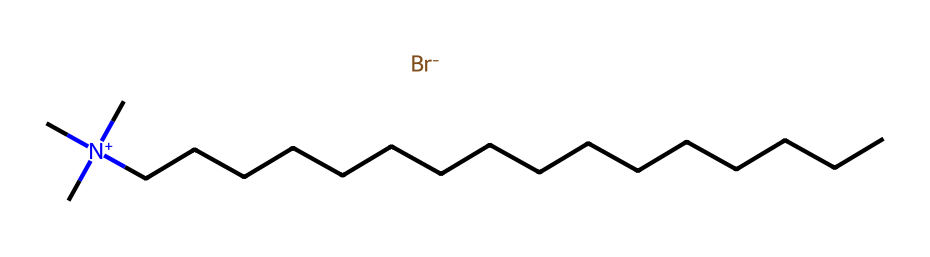What is the total number of carbon atoms in cetrimonium bromide? By examining the SMILES representation, the part "CCCCCCCCCCCCCCCC" indicates a straight chain of 16 carbon atoms, since each "C" represents a carbon atom in the chain.
Answer: 16 How many nitrogen atoms are present in cetrimonium bromide? From the SMILES representation, we see "[N+]" which indicates there is one nitrogen atom in the structure, specifically part of the quaternary ammonium group.
Answer: 1 What type of bond connects the carbon chain to the nitrogen atom? The carbon chain (represented by "CCCCCCCCCCCCCCCC") is connected to the nitrogen through a single bond, as indicated by their direct adjacency in the structure without any other symbols indicating additional bonds.
Answer: single What does the "[Br-]" indicate about the charge of the bromide ion? The "[Br-]" notation indicates that bromine has a negative charge, which signifies that it is acting as an anion in this surfactant, balancing the positive charge of the nitrogen.
Answer: negative What kind of surfactant is cetrimonium bromide classified as? Cetrimonium bromide, characterised by its quaternary ammonium structure with a long hydrophobic carbon chain, is classified as a cationic surfactant due to the presence of the positively charged nitrogen.
Answer: cationic How many methyl groups are present on the nitrogen atom in cetrimonium bromide? The "(C)(C)C" portion indicates there are three methyl groups directly attached to the nitrogen atom, denoting the quaternary ammonium structure of the compound.
Answer: 3 What property of cetrimonium bromide contributes to its use in hair conditioners? The hydrophobic carbon chain allows the compound to interact with hair, providing conditioning properties, while the quaternary ammonium group helps to reduce static and improve manageability.
Answer: conditioning 